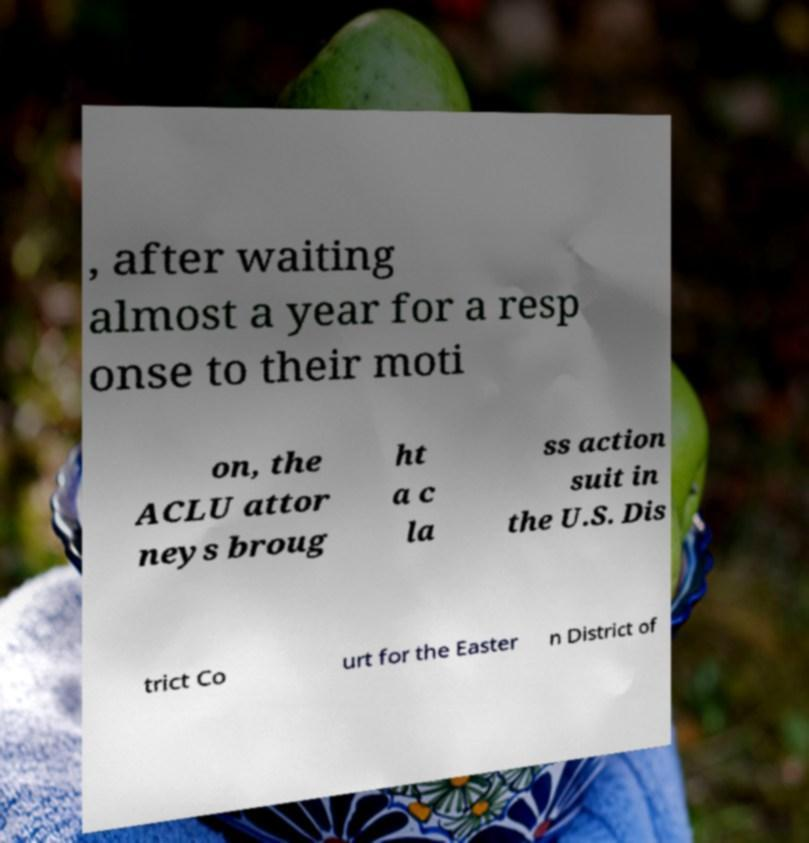I need the written content from this picture converted into text. Can you do that? , after waiting almost a year for a resp onse to their moti on, the ACLU attor neys broug ht a c la ss action suit in the U.S. Dis trict Co urt for the Easter n District of 